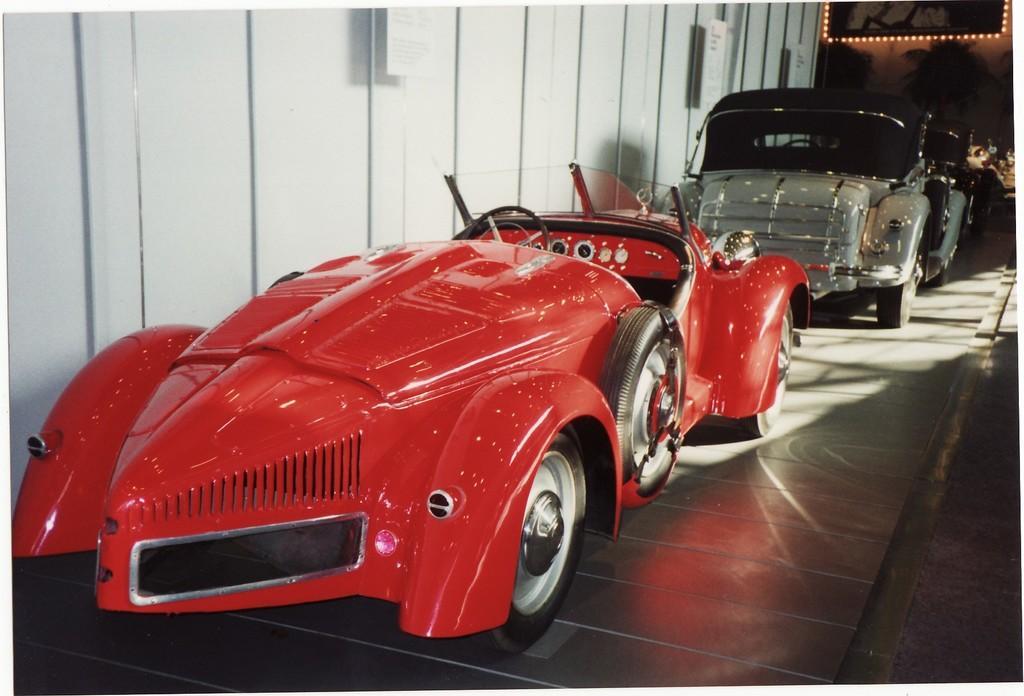How would you summarize this image in a sentence or two? In this picture, there is a car which is in red in color. Behind it, there is another car which is in grey and black in color. On the top, there is a wall with frames. At the bottom, there is a floor. 